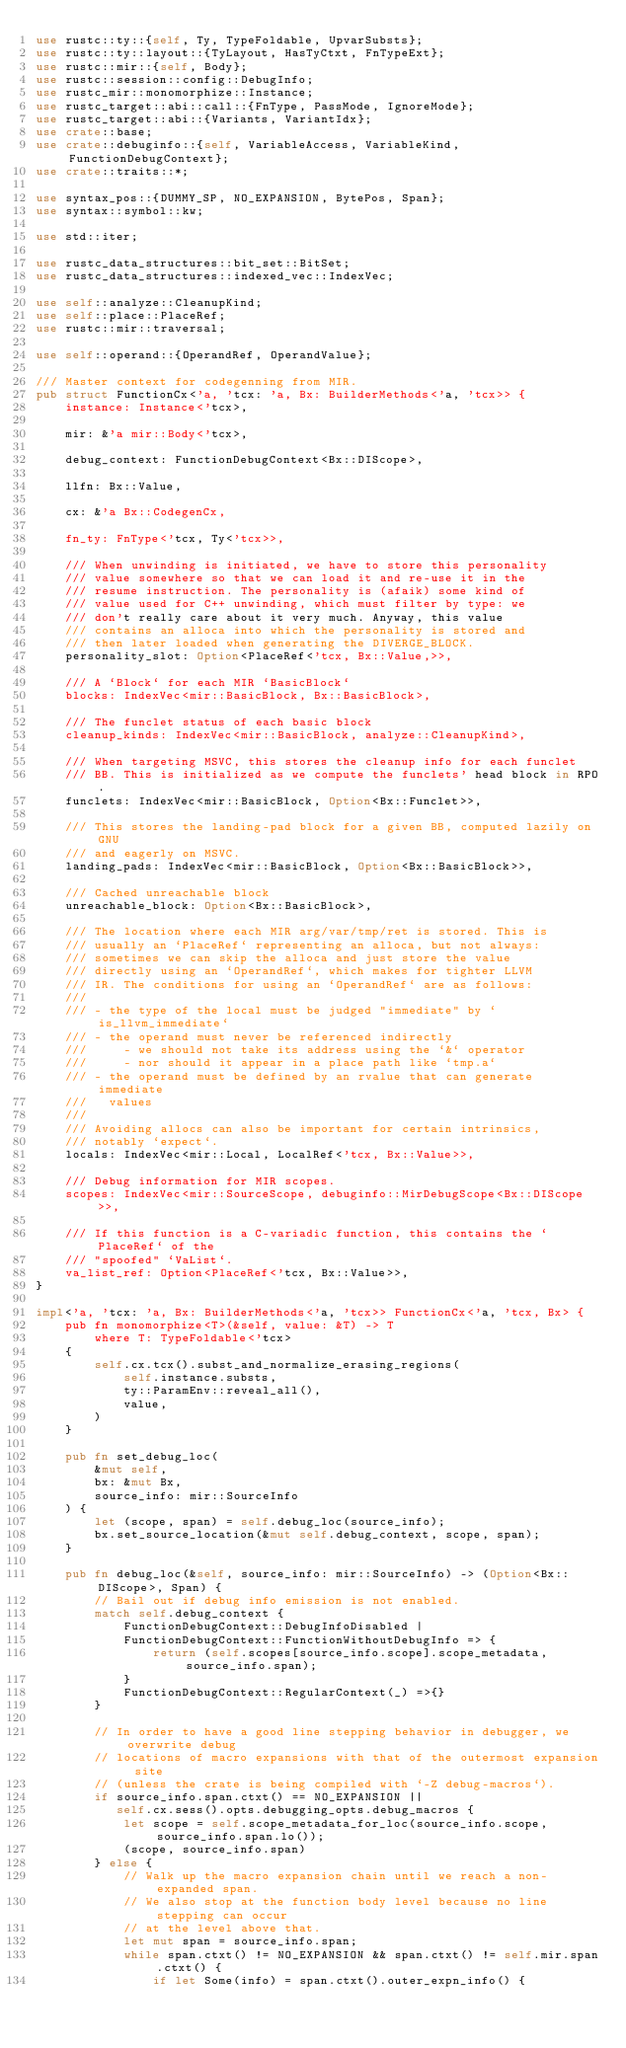Convert code to text. <code><loc_0><loc_0><loc_500><loc_500><_Rust_>use rustc::ty::{self, Ty, TypeFoldable, UpvarSubsts};
use rustc::ty::layout::{TyLayout, HasTyCtxt, FnTypeExt};
use rustc::mir::{self, Body};
use rustc::session::config::DebugInfo;
use rustc_mir::monomorphize::Instance;
use rustc_target::abi::call::{FnType, PassMode, IgnoreMode};
use rustc_target::abi::{Variants, VariantIdx};
use crate::base;
use crate::debuginfo::{self, VariableAccess, VariableKind, FunctionDebugContext};
use crate::traits::*;

use syntax_pos::{DUMMY_SP, NO_EXPANSION, BytePos, Span};
use syntax::symbol::kw;

use std::iter;

use rustc_data_structures::bit_set::BitSet;
use rustc_data_structures::indexed_vec::IndexVec;

use self::analyze::CleanupKind;
use self::place::PlaceRef;
use rustc::mir::traversal;

use self::operand::{OperandRef, OperandValue};

/// Master context for codegenning from MIR.
pub struct FunctionCx<'a, 'tcx: 'a, Bx: BuilderMethods<'a, 'tcx>> {
    instance: Instance<'tcx>,

    mir: &'a mir::Body<'tcx>,

    debug_context: FunctionDebugContext<Bx::DIScope>,

    llfn: Bx::Value,

    cx: &'a Bx::CodegenCx,

    fn_ty: FnType<'tcx, Ty<'tcx>>,

    /// When unwinding is initiated, we have to store this personality
    /// value somewhere so that we can load it and re-use it in the
    /// resume instruction. The personality is (afaik) some kind of
    /// value used for C++ unwinding, which must filter by type: we
    /// don't really care about it very much. Anyway, this value
    /// contains an alloca into which the personality is stored and
    /// then later loaded when generating the DIVERGE_BLOCK.
    personality_slot: Option<PlaceRef<'tcx, Bx::Value,>>,

    /// A `Block` for each MIR `BasicBlock`
    blocks: IndexVec<mir::BasicBlock, Bx::BasicBlock>,

    /// The funclet status of each basic block
    cleanup_kinds: IndexVec<mir::BasicBlock, analyze::CleanupKind>,

    /// When targeting MSVC, this stores the cleanup info for each funclet
    /// BB. This is initialized as we compute the funclets' head block in RPO.
    funclets: IndexVec<mir::BasicBlock, Option<Bx::Funclet>>,

    /// This stores the landing-pad block for a given BB, computed lazily on GNU
    /// and eagerly on MSVC.
    landing_pads: IndexVec<mir::BasicBlock, Option<Bx::BasicBlock>>,

    /// Cached unreachable block
    unreachable_block: Option<Bx::BasicBlock>,

    /// The location where each MIR arg/var/tmp/ret is stored. This is
    /// usually an `PlaceRef` representing an alloca, but not always:
    /// sometimes we can skip the alloca and just store the value
    /// directly using an `OperandRef`, which makes for tighter LLVM
    /// IR. The conditions for using an `OperandRef` are as follows:
    ///
    /// - the type of the local must be judged "immediate" by `is_llvm_immediate`
    /// - the operand must never be referenced indirectly
    ///     - we should not take its address using the `&` operator
    ///     - nor should it appear in a place path like `tmp.a`
    /// - the operand must be defined by an rvalue that can generate immediate
    ///   values
    ///
    /// Avoiding allocs can also be important for certain intrinsics,
    /// notably `expect`.
    locals: IndexVec<mir::Local, LocalRef<'tcx, Bx::Value>>,

    /// Debug information for MIR scopes.
    scopes: IndexVec<mir::SourceScope, debuginfo::MirDebugScope<Bx::DIScope>>,

    /// If this function is a C-variadic function, this contains the `PlaceRef` of the
    /// "spoofed" `VaList`.
    va_list_ref: Option<PlaceRef<'tcx, Bx::Value>>,
}

impl<'a, 'tcx: 'a, Bx: BuilderMethods<'a, 'tcx>> FunctionCx<'a, 'tcx, Bx> {
    pub fn monomorphize<T>(&self, value: &T) -> T
        where T: TypeFoldable<'tcx>
    {
        self.cx.tcx().subst_and_normalize_erasing_regions(
            self.instance.substs,
            ty::ParamEnv::reveal_all(),
            value,
        )
    }

    pub fn set_debug_loc(
        &mut self,
        bx: &mut Bx,
        source_info: mir::SourceInfo
    ) {
        let (scope, span) = self.debug_loc(source_info);
        bx.set_source_location(&mut self.debug_context, scope, span);
    }

    pub fn debug_loc(&self, source_info: mir::SourceInfo) -> (Option<Bx::DIScope>, Span) {
        // Bail out if debug info emission is not enabled.
        match self.debug_context {
            FunctionDebugContext::DebugInfoDisabled |
            FunctionDebugContext::FunctionWithoutDebugInfo => {
                return (self.scopes[source_info.scope].scope_metadata, source_info.span);
            }
            FunctionDebugContext::RegularContext(_) =>{}
        }

        // In order to have a good line stepping behavior in debugger, we overwrite debug
        // locations of macro expansions with that of the outermost expansion site
        // (unless the crate is being compiled with `-Z debug-macros`).
        if source_info.span.ctxt() == NO_EXPANSION ||
           self.cx.sess().opts.debugging_opts.debug_macros {
            let scope = self.scope_metadata_for_loc(source_info.scope, source_info.span.lo());
            (scope, source_info.span)
        } else {
            // Walk up the macro expansion chain until we reach a non-expanded span.
            // We also stop at the function body level because no line stepping can occur
            // at the level above that.
            let mut span = source_info.span;
            while span.ctxt() != NO_EXPANSION && span.ctxt() != self.mir.span.ctxt() {
                if let Some(info) = span.ctxt().outer_expn_info() {</code> 